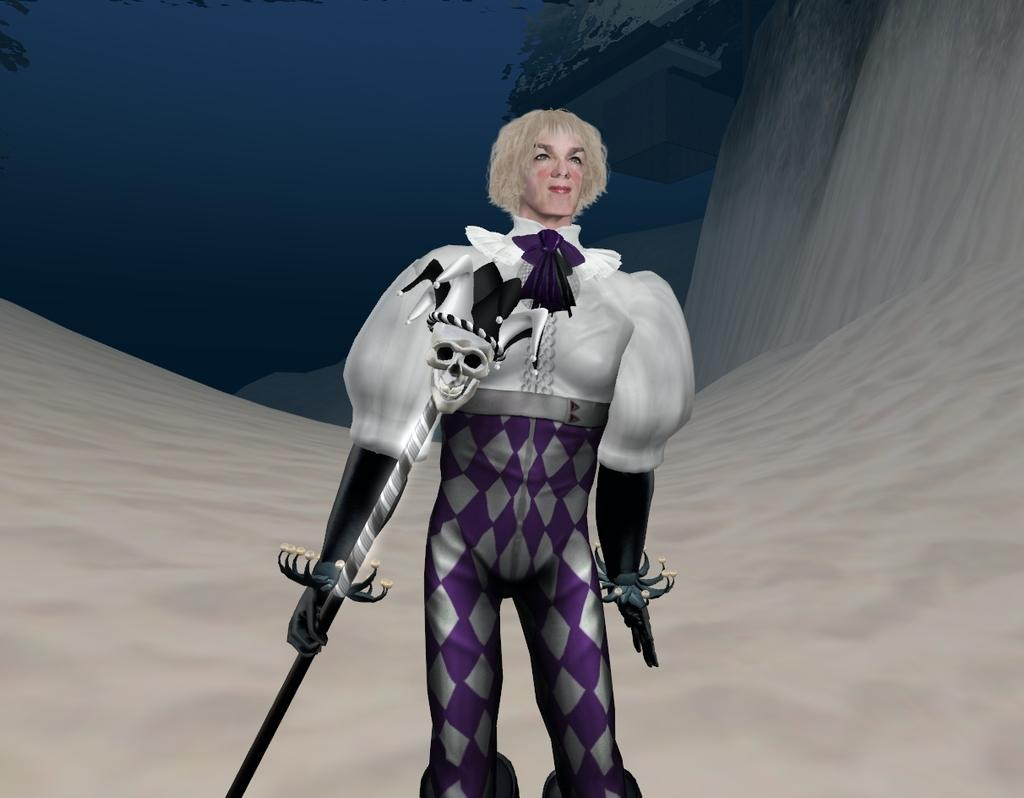What style is the image in? The image is a cartoon. Can you describe the appearance of the cartoon? The cartoon has short hair. What is the cartoon wearing? The cartoon is wearing a different costume. What is the cartoon holding in its hands? The cartoon is holding something in its hands. How does the cartoon use the cannon in the image? There is no cannon present in the image. What type of sky is depicted in the image? The image is a cartoon, and it does not depict a sky. 